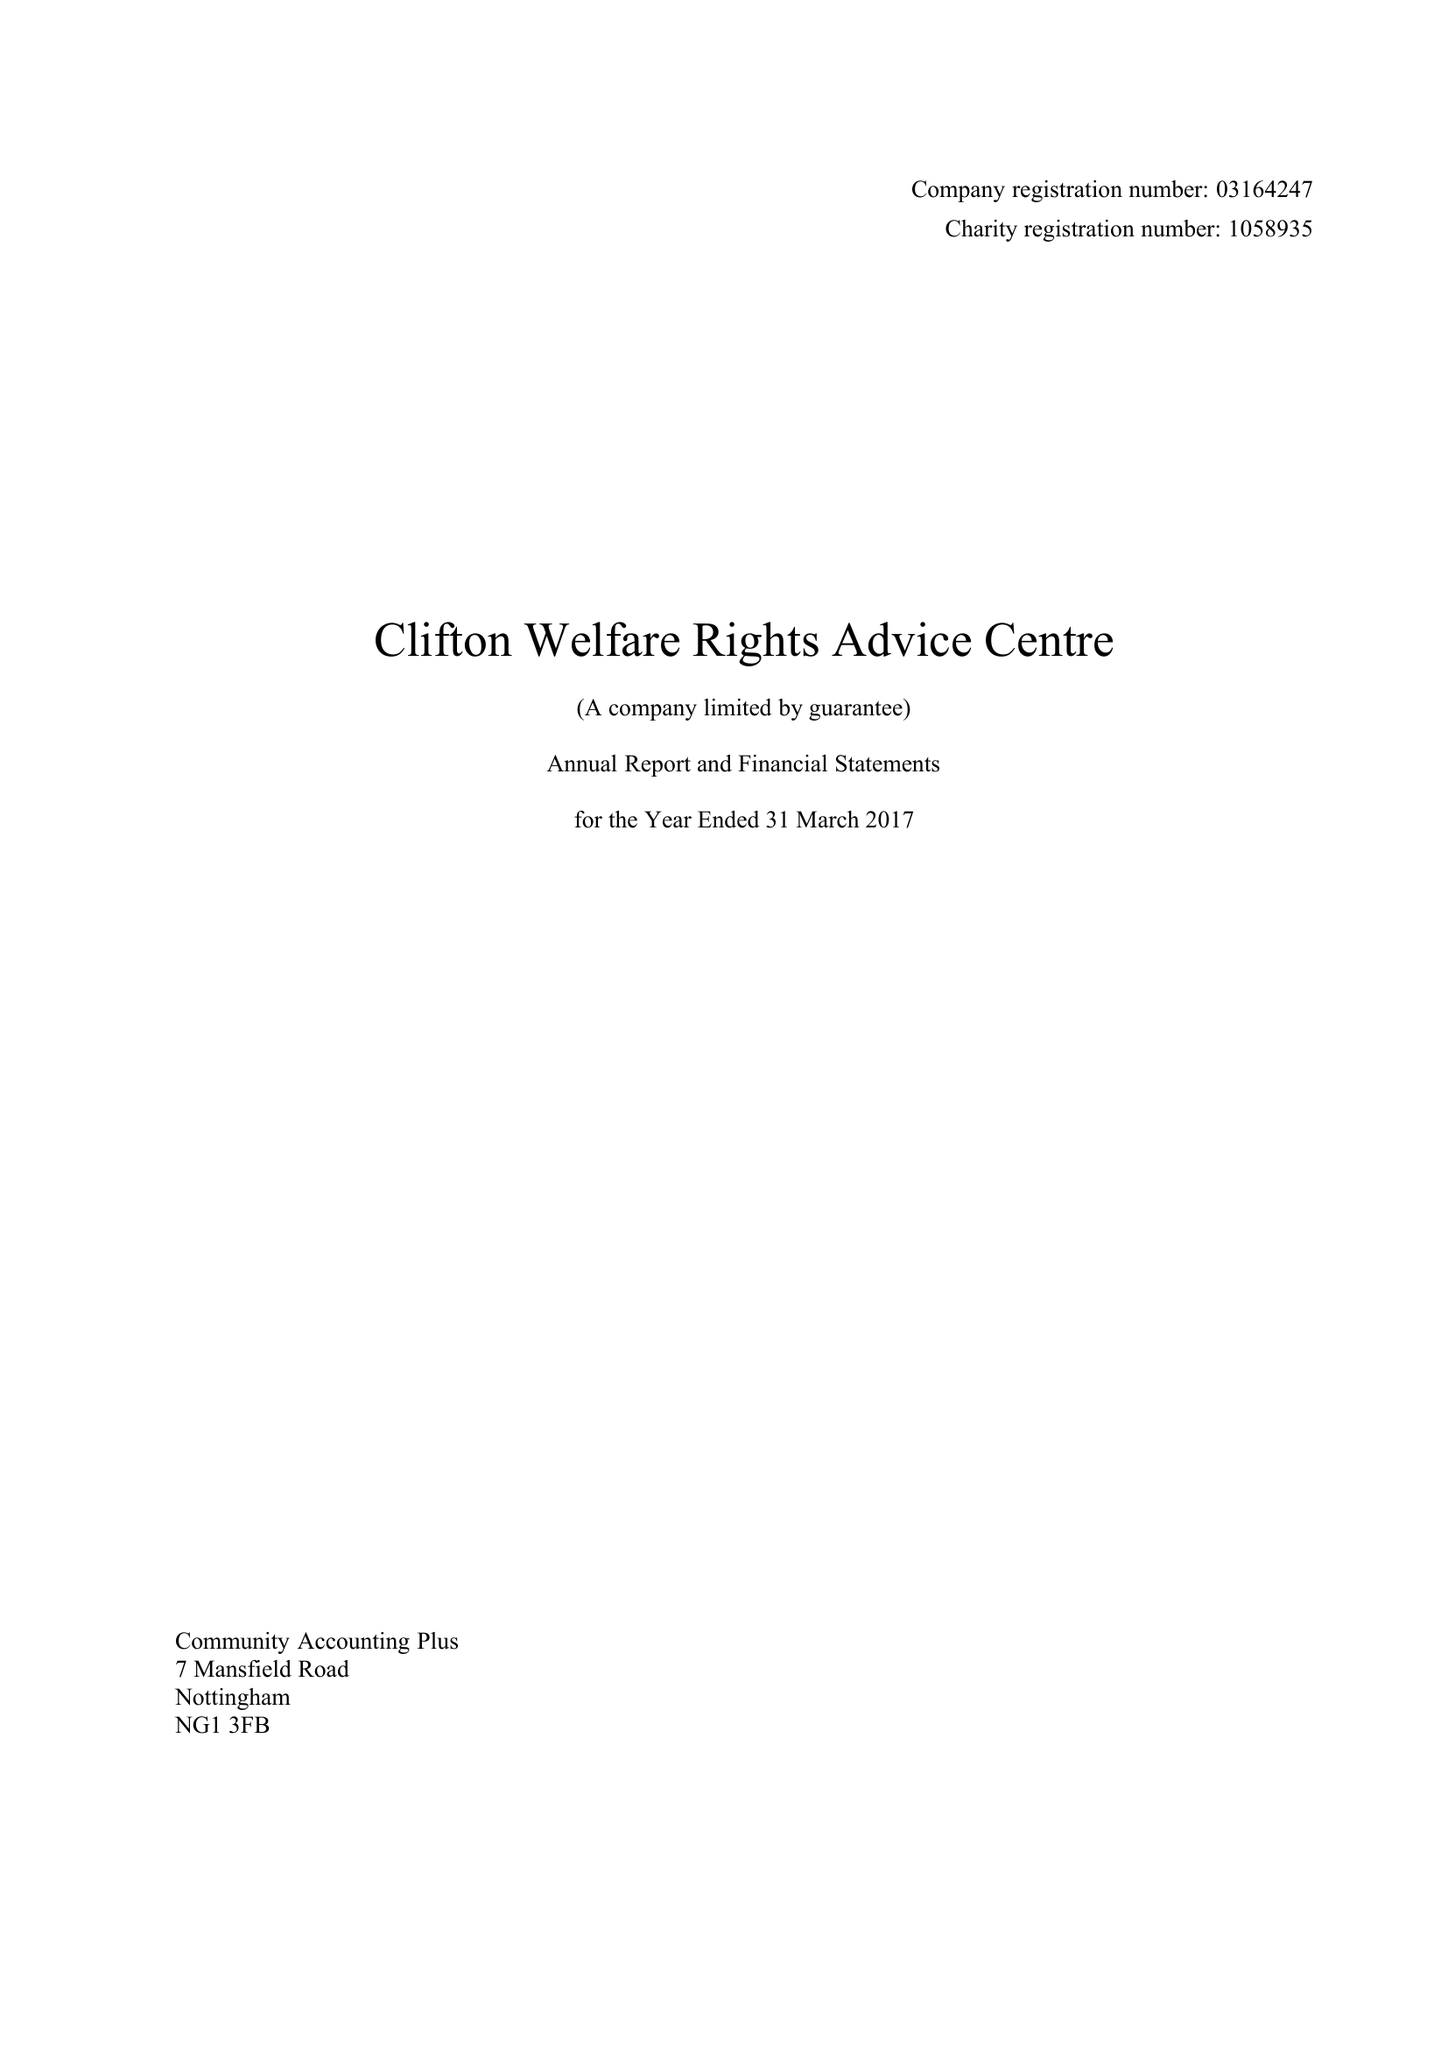What is the value for the charity_number?
Answer the question using a single word or phrase. 1058935 